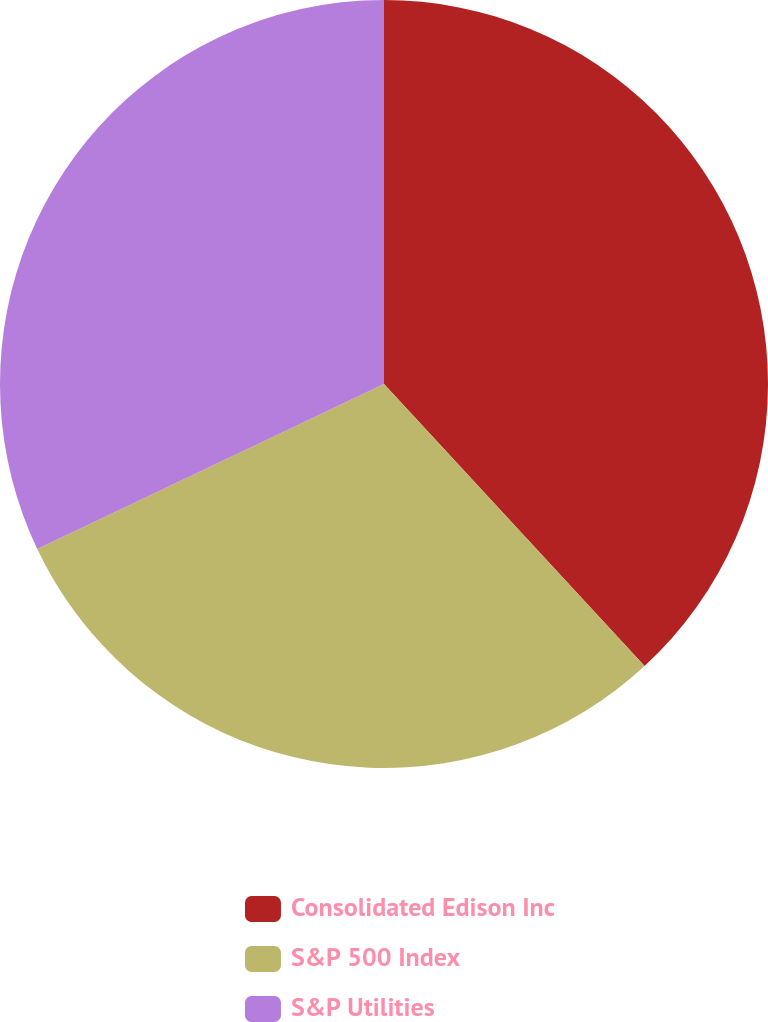Convert chart. <chart><loc_0><loc_0><loc_500><loc_500><pie_chart><fcel>Consolidated Edison Inc<fcel>S&P 500 Index<fcel>S&P Utilities<nl><fcel>38.13%<fcel>29.8%<fcel>32.07%<nl></chart> 